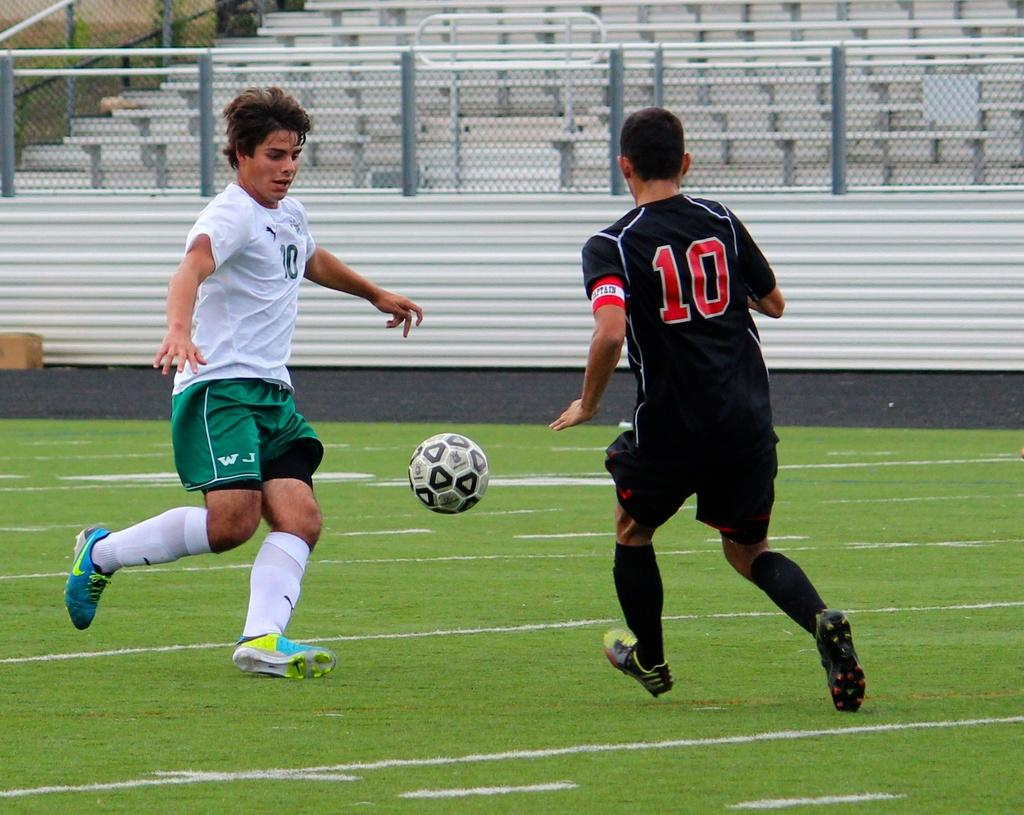<image>
Present a compact description of the photo's key features. number 10 is playing soccer in a black shirt 